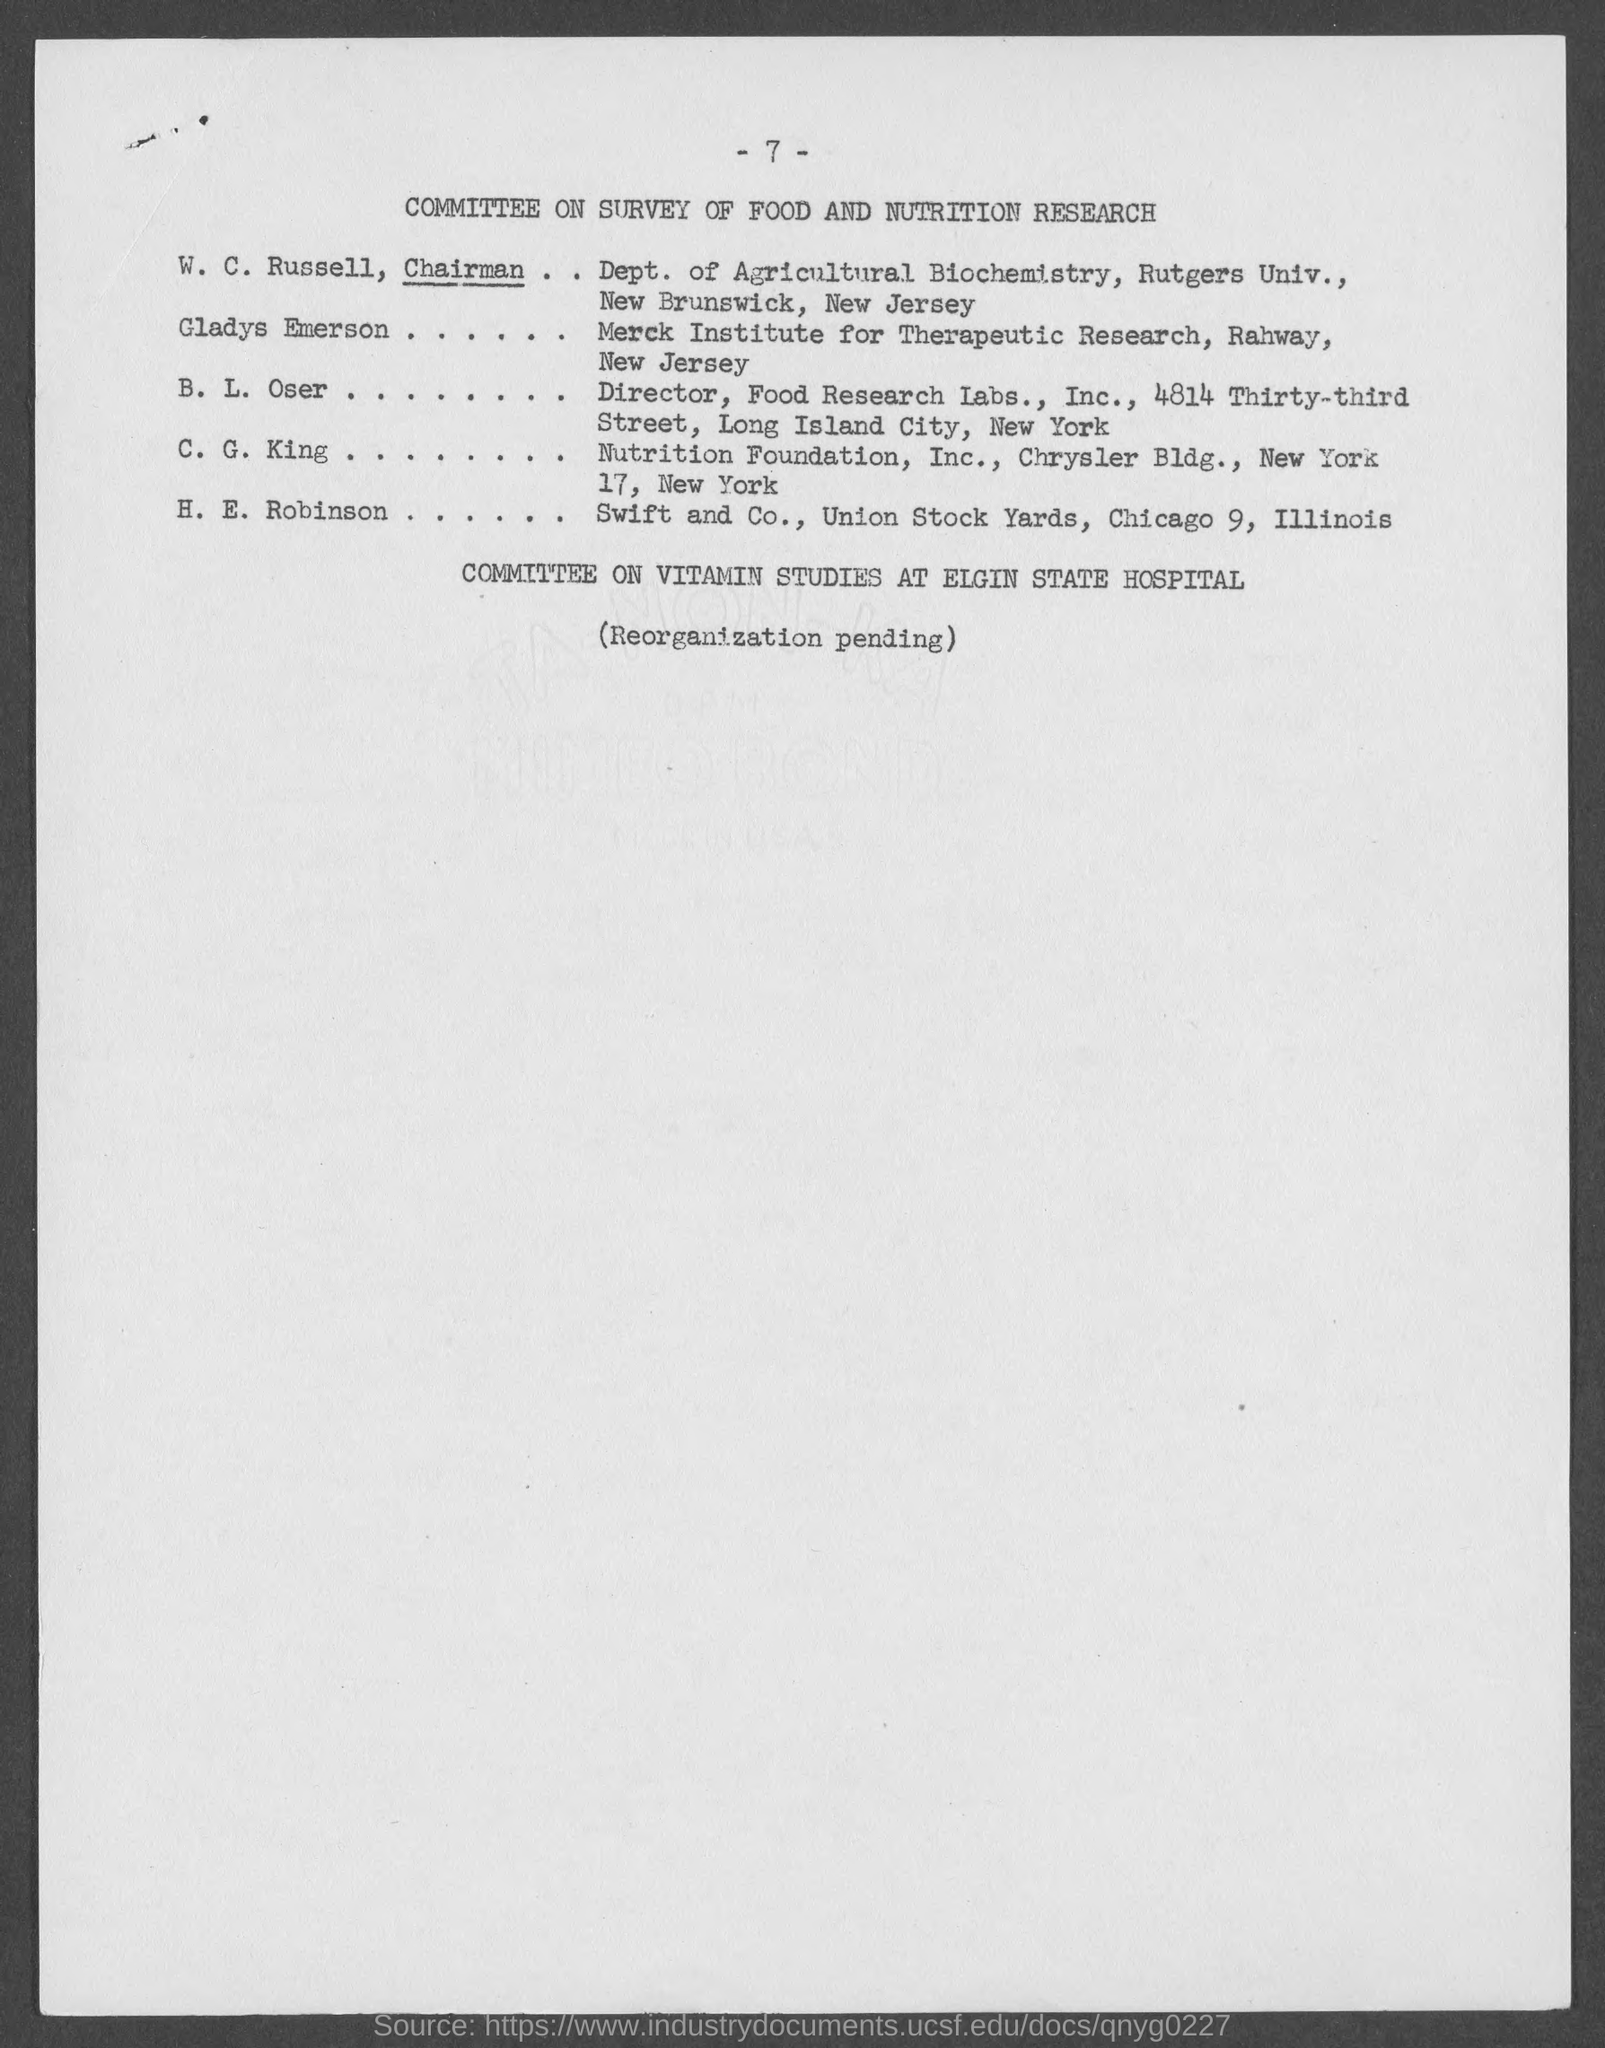What is the page number at top of the page?
Your response must be concise. -7-. What is the title of the page ?
Give a very brief answer. Committee on survey of food and nutrition research. Who is the chairman, dept. of agricultural biochemistry?
Keep it short and to the point. W. C. Russell. To which institute does gladys emerson belong ?
Your response must be concise. Merck Institute for Therapeutic Research. What is the address of nutrition foundation inc.?
Make the answer very short. Chrysler bldg., New york 17, New york. What is the address of swift and co., ?
Offer a very short reply. Union Stock Yards, Chicago 9, Illinois. 